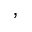Convert formula to latex. <formula><loc_0><loc_0><loc_500><loc_500>,</formula> 